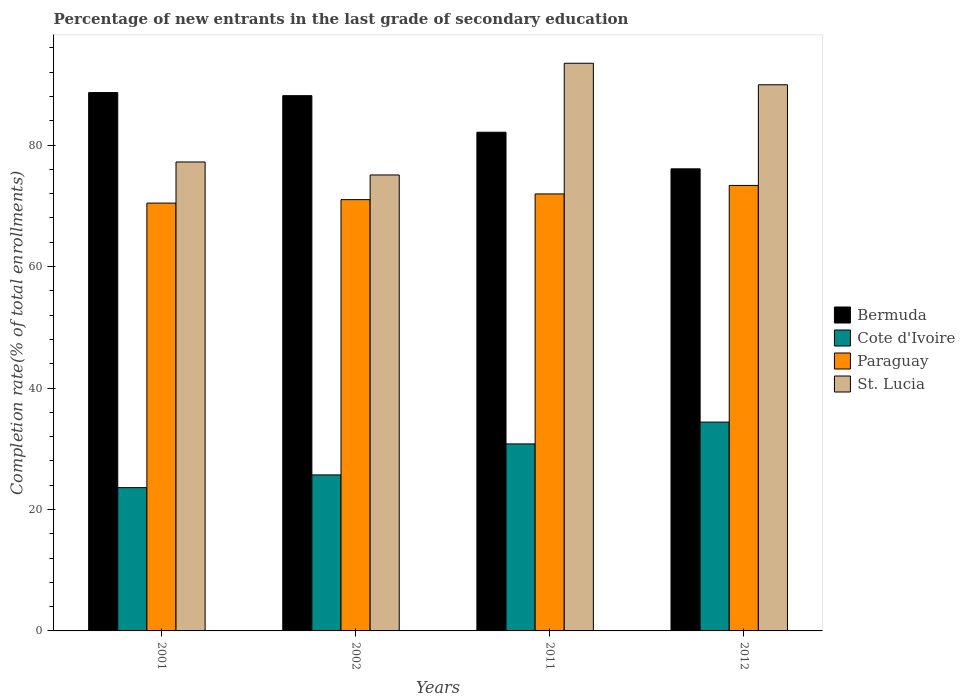How many different coloured bars are there?
Offer a very short reply. 4. Are the number of bars per tick equal to the number of legend labels?
Offer a terse response. Yes. How many bars are there on the 2nd tick from the right?
Keep it short and to the point. 4. What is the label of the 4th group of bars from the left?
Your answer should be compact. 2012. What is the percentage of new entrants in St. Lucia in 2011?
Give a very brief answer. 93.48. Across all years, what is the maximum percentage of new entrants in Cote d'Ivoire?
Provide a succinct answer. 34.39. Across all years, what is the minimum percentage of new entrants in St. Lucia?
Your response must be concise. 75.09. In which year was the percentage of new entrants in Bermuda minimum?
Make the answer very short. 2012. What is the total percentage of new entrants in Cote d'Ivoire in the graph?
Provide a short and direct response. 114.47. What is the difference between the percentage of new entrants in Paraguay in 2002 and that in 2011?
Provide a succinct answer. -0.94. What is the difference between the percentage of new entrants in Paraguay in 2001 and the percentage of new entrants in Cote d'Ivoire in 2012?
Give a very brief answer. 36.07. What is the average percentage of new entrants in Bermuda per year?
Keep it short and to the point. 83.76. In the year 2011, what is the difference between the percentage of new entrants in Paraguay and percentage of new entrants in Cote d'Ivoire?
Give a very brief answer. 41.17. In how many years, is the percentage of new entrants in Paraguay greater than 36 %?
Provide a short and direct response. 4. What is the ratio of the percentage of new entrants in Cote d'Ivoire in 2001 to that in 2012?
Keep it short and to the point. 0.69. Is the percentage of new entrants in Paraguay in 2001 less than that in 2012?
Your answer should be very brief. Yes. Is the difference between the percentage of new entrants in Paraguay in 2011 and 2012 greater than the difference between the percentage of new entrants in Cote d'Ivoire in 2011 and 2012?
Provide a succinct answer. Yes. What is the difference between the highest and the second highest percentage of new entrants in Bermuda?
Your answer should be very brief. 0.51. What is the difference between the highest and the lowest percentage of new entrants in St. Lucia?
Make the answer very short. 18.4. In how many years, is the percentage of new entrants in St. Lucia greater than the average percentage of new entrants in St. Lucia taken over all years?
Ensure brevity in your answer.  2. Is it the case that in every year, the sum of the percentage of new entrants in St. Lucia and percentage of new entrants in Cote d'Ivoire is greater than the sum of percentage of new entrants in Paraguay and percentage of new entrants in Bermuda?
Your answer should be compact. Yes. What does the 2nd bar from the left in 2012 represents?
Offer a terse response. Cote d'Ivoire. What does the 2nd bar from the right in 2002 represents?
Your response must be concise. Paraguay. Are all the bars in the graph horizontal?
Ensure brevity in your answer.  No. How many years are there in the graph?
Provide a succinct answer. 4. What is the difference between two consecutive major ticks on the Y-axis?
Your answer should be very brief. 20. Are the values on the major ticks of Y-axis written in scientific E-notation?
Keep it short and to the point. No. Does the graph contain grids?
Provide a succinct answer. No. How many legend labels are there?
Your answer should be very brief. 4. How are the legend labels stacked?
Give a very brief answer. Vertical. What is the title of the graph?
Make the answer very short. Percentage of new entrants in the last grade of secondary education. What is the label or title of the Y-axis?
Your answer should be compact. Completion rate(% of total enrollments). What is the Completion rate(% of total enrollments) in Bermuda in 2001?
Your response must be concise. 88.65. What is the Completion rate(% of total enrollments) in Cote d'Ivoire in 2001?
Offer a terse response. 23.6. What is the Completion rate(% of total enrollments) of Paraguay in 2001?
Offer a terse response. 70.46. What is the Completion rate(% of total enrollments) in St. Lucia in 2001?
Provide a succinct answer. 77.23. What is the Completion rate(% of total enrollments) of Bermuda in 2002?
Your answer should be very brief. 88.15. What is the Completion rate(% of total enrollments) in Cote d'Ivoire in 2002?
Ensure brevity in your answer.  25.69. What is the Completion rate(% of total enrollments) in Paraguay in 2002?
Offer a very short reply. 71.03. What is the Completion rate(% of total enrollments) of St. Lucia in 2002?
Keep it short and to the point. 75.09. What is the Completion rate(% of total enrollments) of Bermuda in 2011?
Your answer should be compact. 82.12. What is the Completion rate(% of total enrollments) of Cote d'Ivoire in 2011?
Provide a short and direct response. 30.8. What is the Completion rate(% of total enrollments) of Paraguay in 2011?
Offer a terse response. 71.96. What is the Completion rate(% of total enrollments) in St. Lucia in 2011?
Your answer should be compact. 93.48. What is the Completion rate(% of total enrollments) of Bermuda in 2012?
Ensure brevity in your answer.  76.1. What is the Completion rate(% of total enrollments) in Cote d'Ivoire in 2012?
Give a very brief answer. 34.39. What is the Completion rate(% of total enrollments) of Paraguay in 2012?
Offer a very short reply. 73.36. What is the Completion rate(% of total enrollments) in St. Lucia in 2012?
Your answer should be compact. 89.94. Across all years, what is the maximum Completion rate(% of total enrollments) in Bermuda?
Provide a short and direct response. 88.65. Across all years, what is the maximum Completion rate(% of total enrollments) in Cote d'Ivoire?
Make the answer very short. 34.39. Across all years, what is the maximum Completion rate(% of total enrollments) of Paraguay?
Provide a short and direct response. 73.36. Across all years, what is the maximum Completion rate(% of total enrollments) of St. Lucia?
Give a very brief answer. 93.48. Across all years, what is the minimum Completion rate(% of total enrollments) of Bermuda?
Make the answer very short. 76.1. Across all years, what is the minimum Completion rate(% of total enrollments) of Cote d'Ivoire?
Offer a very short reply. 23.6. Across all years, what is the minimum Completion rate(% of total enrollments) of Paraguay?
Your response must be concise. 70.46. Across all years, what is the minimum Completion rate(% of total enrollments) in St. Lucia?
Your response must be concise. 75.09. What is the total Completion rate(% of total enrollments) in Bermuda in the graph?
Make the answer very short. 335.02. What is the total Completion rate(% of total enrollments) of Cote d'Ivoire in the graph?
Offer a very short reply. 114.47. What is the total Completion rate(% of total enrollments) of Paraguay in the graph?
Provide a short and direct response. 286.81. What is the total Completion rate(% of total enrollments) in St. Lucia in the graph?
Offer a terse response. 335.74. What is the difference between the Completion rate(% of total enrollments) of Bermuda in 2001 and that in 2002?
Offer a very short reply. 0.51. What is the difference between the Completion rate(% of total enrollments) in Cote d'Ivoire in 2001 and that in 2002?
Offer a very short reply. -2.1. What is the difference between the Completion rate(% of total enrollments) of Paraguay in 2001 and that in 2002?
Ensure brevity in your answer.  -0.57. What is the difference between the Completion rate(% of total enrollments) in St. Lucia in 2001 and that in 2002?
Ensure brevity in your answer.  2.14. What is the difference between the Completion rate(% of total enrollments) in Bermuda in 2001 and that in 2011?
Make the answer very short. 6.53. What is the difference between the Completion rate(% of total enrollments) of Cote d'Ivoire in 2001 and that in 2011?
Provide a short and direct response. -7.2. What is the difference between the Completion rate(% of total enrollments) of Paraguay in 2001 and that in 2011?
Make the answer very short. -1.51. What is the difference between the Completion rate(% of total enrollments) in St. Lucia in 2001 and that in 2011?
Offer a terse response. -16.26. What is the difference between the Completion rate(% of total enrollments) in Bermuda in 2001 and that in 2012?
Offer a very short reply. 12.56. What is the difference between the Completion rate(% of total enrollments) in Cote d'Ivoire in 2001 and that in 2012?
Offer a very short reply. -10.79. What is the difference between the Completion rate(% of total enrollments) in Paraguay in 2001 and that in 2012?
Ensure brevity in your answer.  -2.91. What is the difference between the Completion rate(% of total enrollments) in St. Lucia in 2001 and that in 2012?
Offer a very short reply. -12.72. What is the difference between the Completion rate(% of total enrollments) of Bermuda in 2002 and that in 2011?
Ensure brevity in your answer.  6.02. What is the difference between the Completion rate(% of total enrollments) of Cote d'Ivoire in 2002 and that in 2011?
Make the answer very short. -5.1. What is the difference between the Completion rate(% of total enrollments) of Paraguay in 2002 and that in 2011?
Provide a succinct answer. -0.94. What is the difference between the Completion rate(% of total enrollments) of St. Lucia in 2002 and that in 2011?
Give a very brief answer. -18.4. What is the difference between the Completion rate(% of total enrollments) of Bermuda in 2002 and that in 2012?
Your answer should be compact. 12.05. What is the difference between the Completion rate(% of total enrollments) in Cote d'Ivoire in 2002 and that in 2012?
Keep it short and to the point. -8.69. What is the difference between the Completion rate(% of total enrollments) in Paraguay in 2002 and that in 2012?
Ensure brevity in your answer.  -2.34. What is the difference between the Completion rate(% of total enrollments) in St. Lucia in 2002 and that in 2012?
Ensure brevity in your answer.  -14.85. What is the difference between the Completion rate(% of total enrollments) in Bermuda in 2011 and that in 2012?
Provide a short and direct response. 6.03. What is the difference between the Completion rate(% of total enrollments) of Cote d'Ivoire in 2011 and that in 2012?
Offer a very short reply. -3.59. What is the difference between the Completion rate(% of total enrollments) in Paraguay in 2011 and that in 2012?
Offer a terse response. -1.4. What is the difference between the Completion rate(% of total enrollments) of St. Lucia in 2011 and that in 2012?
Your answer should be very brief. 3.54. What is the difference between the Completion rate(% of total enrollments) in Bermuda in 2001 and the Completion rate(% of total enrollments) in Cote d'Ivoire in 2002?
Offer a terse response. 62.96. What is the difference between the Completion rate(% of total enrollments) in Bermuda in 2001 and the Completion rate(% of total enrollments) in Paraguay in 2002?
Your answer should be very brief. 17.63. What is the difference between the Completion rate(% of total enrollments) of Bermuda in 2001 and the Completion rate(% of total enrollments) of St. Lucia in 2002?
Give a very brief answer. 13.57. What is the difference between the Completion rate(% of total enrollments) of Cote d'Ivoire in 2001 and the Completion rate(% of total enrollments) of Paraguay in 2002?
Keep it short and to the point. -47.43. What is the difference between the Completion rate(% of total enrollments) in Cote d'Ivoire in 2001 and the Completion rate(% of total enrollments) in St. Lucia in 2002?
Provide a short and direct response. -51.49. What is the difference between the Completion rate(% of total enrollments) of Paraguay in 2001 and the Completion rate(% of total enrollments) of St. Lucia in 2002?
Give a very brief answer. -4.63. What is the difference between the Completion rate(% of total enrollments) in Bermuda in 2001 and the Completion rate(% of total enrollments) in Cote d'Ivoire in 2011?
Provide a short and direct response. 57.86. What is the difference between the Completion rate(% of total enrollments) of Bermuda in 2001 and the Completion rate(% of total enrollments) of Paraguay in 2011?
Keep it short and to the point. 16.69. What is the difference between the Completion rate(% of total enrollments) in Bermuda in 2001 and the Completion rate(% of total enrollments) in St. Lucia in 2011?
Your answer should be very brief. -4.83. What is the difference between the Completion rate(% of total enrollments) of Cote d'Ivoire in 2001 and the Completion rate(% of total enrollments) of Paraguay in 2011?
Provide a succinct answer. -48.37. What is the difference between the Completion rate(% of total enrollments) in Cote d'Ivoire in 2001 and the Completion rate(% of total enrollments) in St. Lucia in 2011?
Offer a very short reply. -69.89. What is the difference between the Completion rate(% of total enrollments) of Paraguay in 2001 and the Completion rate(% of total enrollments) of St. Lucia in 2011?
Ensure brevity in your answer.  -23.03. What is the difference between the Completion rate(% of total enrollments) of Bermuda in 2001 and the Completion rate(% of total enrollments) of Cote d'Ivoire in 2012?
Offer a very short reply. 54.27. What is the difference between the Completion rate(% of total enrollments) of Bermuda in 2001 and the Completion rate(% of total enrollments) of Paraguay in 2012?
Your answer should be very brief. 15.29. What is the difference between the Completion rate(% of total enrollments) of Bermuda in 2001 and the Completion rate(% of total enrollments) of St. Lucia in 2012?
Ensure brevity in your answer.  -1.29. What is the difference between the Completion rate(% of total enrollments) in Cote d'Ivoire in 2001 and the Completion rate(% of total enrollments) in Paraguay in 2012?
Provide a short and direct response. -49.77. What is the difference between the Completion rate(% of total enrollments) in Cote d'Ivoire in 2001 and the Completion rate(% of total enrollments) in St. Lucia in 2012?
Give a very brief answer. -66.34. What is the difference between the Completion rate(% of total enrollments) in Paraguay in 2001 and the Completion rate(% of total enrollments) in St. Lucia in 2012?
Your answer should be very brief. -19.48. What is the difference between the Completion rate(% of total enrollments) in Bermuda in 2002 and the Completion rate(% of total enrollments) in Cote d'Ivoire in 2011?
Your answer should be compact. 57.35. What is the difference between the Completion rate(% of total enrollments) in Bermuda in 2002 and the Completion rate(% of total enrollments) in Paraguay in 2011?
Provide a short and direct response. 16.18. What is the difference between the Completion rate(% of total enrollments) of Bermuda in 2002 and the Completion rate(% of total enrollments) of St. Lucia in 2011?
Offer a terse response. -5.34. What is the difference between the Completion rate(% of total enrollments) in Cote d'Ivoire in 2002 and the Completion rate(% of total enrollments) in Paraguay in 2011?
Ensure brevity in your answer.  -46.27. What is the difference between the Completion rate(% of total enrollments) in Cote d'Ivoire in 2002 and the Completion rate(% of total enrollments) in St. Lucia in 2011?
Offer a terse response. -67.79. What is the difference between the Completion rate(% of total enrollments) in Paraguay in 2002 and the Completion rate(% of total enrollments) in St. Lucia in 2011?
Provide a succinct answer. -22.46. What is the difference between the Completion rate(% of total enrollments) of Bermuda in 2002 and the Completion rate(% of total enrollments) of Cote d'Ivoire in 2012?
Provide a short and direct response. 53.76. What is the difference between the Completion rate(% of total enrollments) in Bermuda in 2002 and the Completion rate(% of total enrollments) in Paraguay in 2012?
Provide a succinct answer. 14.78. What is the difference between the Completion rate(% of total enrollments) in Bermuda in 2002 and the Completion rate(% of total enrollments) in St. Lucia in 2012?
Keep it short and to the point. -1.79. What is the difference between the Completion rate(% of total enrollments) of Cote d'Ivoire in 2002 and the Completion rate(% of total enrollments) of Paraguay in 2012?
Keep it short and to the point. -47.67. What is the difference between the Completion rate(% of total enrollments) of Cote d'Ivoire in 2002 and the Completion rate(% of total enrollments) of St. Lucia in 2012?
Provide a succinct answer. -64.25. What is the difference between the Completion rate(% of total enrollments) of Paraguay in 2002 and the Completion rate(% of total enrollments) of St. Lucia in 2012?
Offer a very short reply. -18.92. What is the difference between the Completion rate(% of total enrollments) of Bermuda in 2011 and the Completion rate(% of total enrollments) of Cote d'Ivoire in 2012?
Ensure brevity in your answer.  47.74. What is the difference between the Completion rate(% of total enrollments) of Bermuda in 2011 and the Completion rate(% of total enrollments) of Paraguay in 2012?
Your response must be concise. 8.76. What is the difference between the Completion rate(% of total enrollments) in Bermuda in 2011 and the Completion rate(% of total enrollments) in St. Lucia in 2012?
Keep it short and to the point. -7.82. What is the difference between the Completion rate(% of total enrollments) in Cote d'Ivoire in 2011 and the Completion rate(% of total enrollments) in Paraguay in 2012?
Give a very brief answer. -42.57. What is the difference between the Completion rate(% of total enrollments) of Cote d'Ivoire in 2011 and the Completion rate(% of total enrollments) of St. Lucia in 2012?
Offer a very short reply. -59.14. What is the difference between the Completion rate(% of total enrollments) of Paraguay in 2011 and the Completion rate(% of total enrollments) of St. Lucia in 2012?
Ensure brevity in your answer.  -17.98. What is the average Completion rate(% of total enrollments) of Bermuda per year?
Provide a succinct answer. 83.76. What is the average Completion rate(% of total enrollments) of Cote d'Ivoire per year?
Provide a short and direct response. 28.62. What is the average Completion rate(% of total enrollments) of Paraguay per year?
Offer a very short reply. 71.7. What is the average Completion rate(% of total enrollments) of St. Lucia per year?
Offer a very short reply. 83.93. In the year 2001, what is the difference between the Completion rate(% of total enrollments) of Bermuda and Completion rate(% of total enrollments) of Cote d'Ivoire?
Your response must be concise. 65.06. In the year 2001, what is the difference between the Completion rate(% of total enrollments) of Bermuda and Completion rate(% of total enrollments) of Paraguay?
Your answer should be very brief. 18.2. In the year 2001, what is the difference between the Completion rate(% of total enrollments) of Bermuda and Completion rate(% of total enrollments) of St. Lucia?
Your answer should be compact. 11.43. In the year 2001, what is the difference between the Completion rate(% of total enrollments) in Cote d'Ivoire and Completion rate(% of total enrollments) in Paraguay?
Provide a succinct answer. -46.86. In the year 2001, what is the difference between the Completion rate(% of total enrollments) in Cote d'Ivoire and Completion rate(% of total enrollments) in St. Lucia?
Keep it short and to the point. -53.63. In the year 2001, what is the difference between the Completion rate(% of total enrollments) in Paraguay and Completion rate(% of total enrollments) in St. Lucia?
Offer a terse response. -6.77. In the year 2002, what is the difference between the Completion rate(% of total enrollments) of Bermuda and Completion rate(% of total enrollments) of Cote d'Ivoire?
Keep it short and to the point. 62.45. In the year 2002, what is the difference between the Completion rate(% of total enrollments) in Bermuda and Completion rate(% of total enrollments) in Paraguay?
Ensure brevity in your answer.  17.12. In the year 2002, what is the difference between the Completion rate(% of total enrollments) in Bermuda and Completion rate(% of total enrollments) in St. Lucia?
Give a very brief answer. 13.06. In the year 2002, what is the difference between the Completion rate(% of total enrollments) of Cote d'Ivoire and Completion rate(% of total enrollments) of Paraguay?
Make the answer very short. -45.33. In the year 2002, what is the difference between the Completion rate(% of total enrollments) of Cote d'Ivoire and Completion rate(% of total enrollments) of St. Lucia?
Your answer should be compact. -49.39. In the year 2002, what is the difference between the Completion rate(% of total enrollments) of Paraguay and Completion rate(% of total enrollments) of St. Lucia?
Give a very brief answer. -4.06. In the year 2011, what is the difference between the Completion rate(% of total enrollments) of Bermuda and Completion rate(% of total enrollments) of Cote d'Ivoire?
Make the answer very short. 51.33. In the year 2011, what is the difference between the Completion rate(% of total enrollments) in Bermuda and Completion rate(% of total enrollments) in Paraguay?
Your response must be concise. 10.16. In the year 2011, what is the difference between the Completion rate(% of total enrollments) in Bermuda and Completion rate(% of total enrollments) in St. Lucia?
Make the answer very short. -11.36. In the year 2011, what is the difference between the Completion rate(% of total enrollments) of Cote d'Ivoire and Completion rate(% of total enrollments) of Paraguay?
Your response must be concise. -41.17. In the year 2011, what is the difference between the Completion rate(% of total enrollments) in Cote d'Ivoire and Completion rate(% of total enrollments) in St. Lucia?
Give a very brief answer. -62.69. In the year 2011, what is the difference between the Completion rate(% of total enrollments) in Paraguay and Completion rate(% of total enrollments) in St. Lucia?
Keep it short and to the point. -21.52. In the year 2012, what is the difference between the Completion rate(% of total enrollments) in Bermuda and Completion rate(% of total enrollments) in Cote d'Ivoire?
Keep it short and to the point. 41.71. In the year 2012, what is the difference between the Completion rate(% of total enrollments) in Bermuda and Completion rate(% of total enrollments) in Paraguay?
Offer a very short reply. 2.73. In the year 2012, what is the difference between the Completion rate(% of total enrollments) in Bermuda and Completion rate(% of total enrollments) in St. Lucia?
Your response must be concise. -13.85. In the year 2012, what is the difference between the Completion rate(% of total enrollments) of Cote d'Ivoire and Completion rate(% of total enrollments) of Paraguay?
Keep it short and to the point. -38.98. In the year 2012, what is the difference between the Completion rate(% of total enrollments) in Cote d'Ivoire and Completion rate(% of total enrollments) in St. Lucia?
Offer a very short reply. -55.55. In the year 2012, what is the difference between the Completion rate(% of total enrollments) of Paraguay and Completion rate(% of total enrollments) of St. Lucia?
Offer a very short reply. -16.58. What is the ratio of the Completion rate(% of total enrollments) of Bermuda in 2001 to that in 2002?
Offer a very short reply. 1.01. What is the ratio of the Completion rate(% of total enrollments) in Cote d'Ivoire in 2001 to that in 2002?
Your answer should be very brief. 0.92. What is the ratio of the Completion rate(% of total enrollments) of Paraguay in 2001 to that in 2002?
Provide a short and direct response. 0.99. What is the ratio of the Completion rate(% of total enrollments) in St. Lucia in 2001 to that in 2002?
Offer a very short reply. 1.03. What is the ratio of the Completion rate(% of total enrollments) in Bermuda in 2001 to that in 2011?
Provide a short and direct response. 1.08. What is the ratio of the Completion rate(% of total enrollments) in Cote d'Ivoire in 2001 to that in 2011?
Ensure brevity in your answer.  0.77. What is the ratio of the Completion rate(% of total enrollments) in Paraguay in 2001 to that in 2011?
Your response must be concise. 0.98. What is the ratio of the Completion rate(% of total enrollments) of St. Lucia in 2001 to that in 2011?
Provide a succinct answer. 0.83. What is the ratio of the Completion rate(% of total enrollments) in Bermuda in 2001 to that in 2012?
Provide a succinct answer. 1.17. What is the ratio of the Completion rate(% of total enrollments) in Cote d'Ivoire in 2001 to that in 2012?
Your answer should be compact. 0.69. What is the ratio of the Completion rate(% of total enrollments) in Paraguay in 2001 to that in 2012?
Offer a very short reply. 0.96. What is the ratio of the Completion rate(% of total enrollments) in St. Lucia in 2001 to that in 2012?
Give a very brief answer. 0.86. What is the ratio of the Completion rate(% of total enrollments) of Bermuda in 2002 to that in 2011?
Make the answer very short. 1.07. What is the ratio of the Completion rate(% of total enrollments) in Cote d'Ivoire in 2002 to that in 2011?
Your answer should be compact. 0.83. What is the ratio of the Completion rate(% of total enrollments) in St. Lucia in 2002 to that in 2011?
Give a very brief answer. 0.8. What is the ratio of the Completion rate(% of total enrollments) in Bermuda in 2002 to that in 2012?
Provide a succinct answer. 1.16. What is the ratio of the Completion rate(% of total enrollments) in Cote d'Ivoire in 2002 to that in 2012?
Your answer should be very brief. 0.75. What is the ratio of the Completion rate(% of total enrollments) in Paraguay in 2002 to that in 2012?
Make the answer very short. 0.97. What is the ratio of the Completion rate(% of total enrollments) of St. Lucia in 2002 to that in 2012?
Offer a very short reply. 0.83. What is the ratio of the Completion rate(% of total enrollments) in Bermuda in 2011 to that in 2012?
Your response must be concise. 1.08. What is the ratio of the Completion rate(% of total enrollments) in Cote d'Ivoire in 2011 to that in 2012?
Your response must be concise. 0.9. What is the ratio of the Completion rate(% of total enrollments) of Paraguay in 2011 to that in 2012?
Offer a terse response. 0.98. What is the ratio of the Completion rate(% of total enrollments) of St. Lucia in 2011 to that in 2012?
Ensure brevity in your answer.  1.04. What is the difference between the highest and the second highest Completion rate(% of total enrollments) in Bermuda?
Give a very brief answer. 0.51. What is the difference between the highest and the second highest Completion rate(% of total enrollments) in Cote d'Ivoire?
Give a very brief answer. 3.59. What is the difference between the highest and the second highest Completion rate(% of total enrollments) of Paraguay?
Keep it short and to the point. 1.4. What is the difference between the highest and the second highest Completion rate(% of total enrollments) in St. Lucia?
Your response must be concise. 3.54. What is the difference between the highest and the lowest Completion rate(% of total enrollments) of Bermuda?
Make the answer very short. 12.56. What is the difference between the highest and the lowest Completion rate(% of total enrollments) of Cote d'Ivoire?
Ensure brevity in your answer.  10.79. What is the difference between the highest and the lowest Completion rate(% of total enrollments) in Paraguay?
Offer a terse response. 2.91. What is the difference between the highest and the lowest Completion rate(% of total enrollments) of St. Lucia?
Your response must be concise. 18.4. 